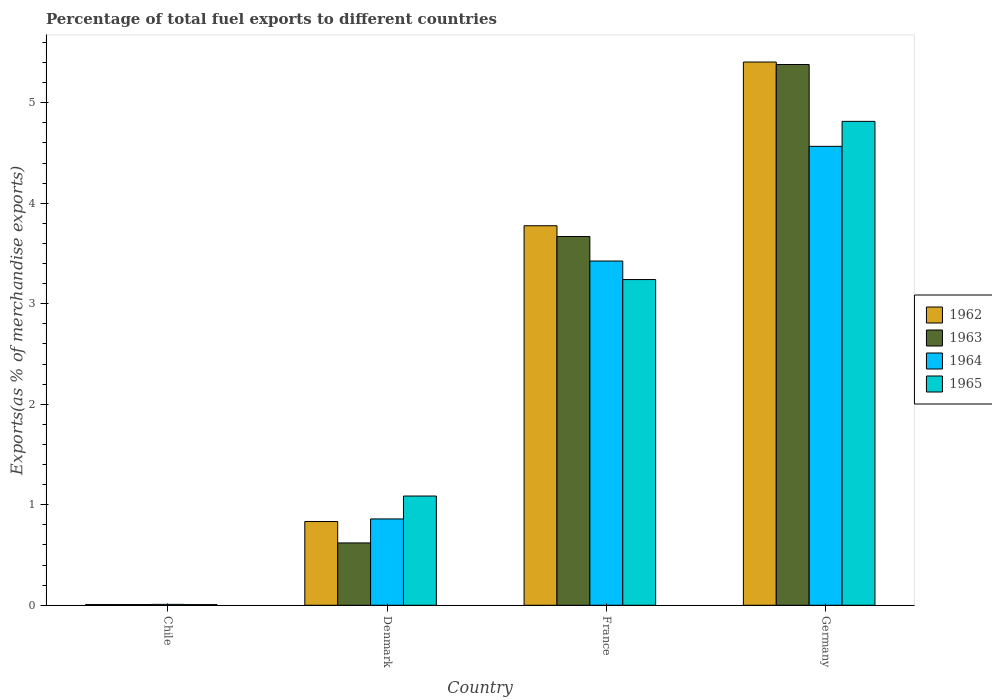How many groups of bars are there?
Ensure brevity in your answer.  4. Are the number of bars on each tick of the X-axis equal?
Make the answer very short. Yes. In how many cases, is the number of bars for a given country not equal to the number of legend labels?
Ensure brevity in your answer.  0. What is the percentage of exports to different countries in 1962 in Denmark?
Give a very brief answer. 0.83. Across all countries, what is the maximum percentage of exports to different countries in 1962?
Give a very brief answer. 5.4. Across all countries, what is the minimum percentage of exports to different countries in 1965?
Your response must be concise. 0.01. In which country was the percentage of exports to different countries in 1962 maximum?
Your answer should be very brief. Germany. What is the total percentage of exports to different countries in 1963 in the graph?
Your answer should be very brief. 9.68. What is the difference between the percentage of exports to different countries in 1962 in Chile and that in Denmark?
Keep it short and to the point. -0.83. What is the difference between the percentage of exports to different countries in 1962 in Chile and the percentage of exports to different countries in 1965 in Denmark?
Your response must be concise. -1.08. What is the average percentage of exports to different countries in 1962 per country?
Offer a very short reply. 2.51. What is the difference between the percentage of exports to different countries of/in 1962 and percentage of exports to different countries of/in 1963 in Denmark?
Provide a succinct answer. 0.21. What is the ratio of the percentage of exports to different countries in 1963 in Denmark to that in France?
Make the answer very short. 0.17. Is the percentage of exports to different countries in 1963 in Chile less than that in Denmark?
Ensure brevity in your answer.  Yes. Is the difference between the percentage of exports to different countries in 1962 in France and Germany greater than the difference between the percentage of exports to different countries in 1963 in France and Germany?
Provide a short and direct response. Yes. What is the difference between the highest and the second highest percentage of exports to different countries in 1965?
Make the answer very short. -2.15. What is the difference between the highest and the lowest percentage of exports to different countries in 1963?
Your response must be concise. 5.37. What does the 2nd bar from the left in Denmark represents?
Provide a short and direct response. 1963. What does the 1st bar from the right in Denmark represents?
Offer a very short reply. 1965. Is it the case that in every country, the sum of the percentage of exports to different countries in 1962 and percentage of exports to different countries in 1963 is greater than the percentage of exports to different countries in 1964?
Offer a very short reply. Yes. Are the values on the major ticks of Y-axis written in scientific E-notation?
Make the answer very short. No. Does the graph contain grids?
Offer a very short reply. No. Where does the legend appear in the graph?
Your answer should be very brief. Center right. How are the legend labels stacked?
Your response must be concise. Vertical. What is the title of the graph?
Provide a short and direct response. Percentage of total fuel exports to different countries. What is the label or title of the X-axis?
Your answer should be compact. Country. What is the label or title of the Y-axis?
Keep it short and to the point. Exports(as % of merchandise exports). What is the Exports(as % of merchandise exports) in 1962 in Chile?
Make the answer very short. 0.01. What is the Exports(as % of merchandise exports) of 1963 in Chile?
Provide a succinct answer. 0.01. What is the Exports(as % of merchandise exports) in 1964 in Chile?
Ensure brevity in your answer.  0.01. What is the Exports(as % of merchandise exports) of 1965 in Chile?
Offer a very short reply. 0.01. What is the Exports(as % of merchandise exports) in 1962 in Denmark?
Provide a short and direct response. 0.83. What is the Exports(as % of merchandise exports) in 1963 in Denmark?
Keep it short and to the point. 0.62. What is the Exports(as % of merchandise exports) in 1964 in Denmark?
Give a very brief answer. 0.86. What is the Exports(as % of merchandise exports) in 1965 in Denmark?
Make the answer very short. 1.09. What is the Exports(as % of merchandise exports) in 1962 in France?
Offer a very short reply. 3.78. What is the Exports(as % of merchandise exports) in 1963 in France?
Give a very brief answer. 3.67. What is the Exports(as % of merchandise exports) in 1964 in France?
Give a very brief answer. 3.43. What is the Exports(as % of merchandise exports) in 1965 in France?
Offer a terse response. 3.24. What is the Exports(as % of merchandise exports) in 1962 in Germany?
Your answer should be compact. 5.4. What is the Exports(as % of merchandise exports) in 1963 in Germany?
Your response must be concise. 5.38. What is the Exports(as % of merchandise exports) of 1964 in Germany?
Provide a short and direct response. 4.57. What is the Exports(as % of merchandise exports) in 1965 in Germany?
Ensure brevity in your answer.  4.81. Across all countries, what is the maximum Exports(as % of merchandise exports) in 1962?
Give a very brief answer. 5.4. Across all countries, what is the maximum Exports(as % of merchandise exports) of 1963?
Offer a very short reply. 5.38. Across all countries, what is the maximum Exports(as % of merchandise exports) in 1964?
Your response must be concise. 4.57. Across all countries, what is the maximum Exports(as % of merchandise exports) of 1965?
Offer a terse response. 4.81. Across all countries, what is the minimum Exports(as % of merchandise exports) of 1962?
Provide a short and direct response. 0.01. Across all countries, what is the minimum Exports(as % of merchandise exports) in 1963?
Give a very brief answer. 0.01. Across all countries, what is the minimum Exports(as % of merchandise exports) in 1964?
Offer a very short reply. 0.01. Across all countries, what is the minimum Exports(as % of merchandise exports) in 1965?
Make the answer very short. 0.01. What is the total Exports(as % of merchandise exports) of 1962 in the graph?
Provide a succinct answer. 10.02. What is the total Exports(as % of merchandise exports) of 1963 in the graph?
Offer a very short reply. 9.68. What is the total Exports(as % of merchandise exports) in 1964 in the graph?
Your response must be concise. 8.86. What is the total Exports(as % of merchandise exports) of 1965 in the graph?
Offer a terse response. 9.15. What is the difference between the Exports(as % of merchandise exports) in 1962 in Chile and that in Denmark?
Provide a succinct answer. -0.83. What is the difference between the Exports(as % of merchandise exports) of 1963 in Chile and that in Denmark?
Ensure brevity in your answer.  -0.61. What is the difference between the Exports(as % of merchandise exports) of 1964 in Chile and that in Denmark?
Your answer should be compact. -0.85. What is the difference between the Exports(as % of merchandise exports) in 1965 in Chile and that in Denmark?
Offer a very short reply. -1.08. What is the difference between the Exports(as % of merchandise exports) in 1962 in Chile and that in France?
Your answer should be compact. -3.77. What is the difference between the Exports(as % of merchandise exports) of 1963 in Chile and that in France?
Offer a very short reply. -3.66. What is the difference between the Exports(as % of merchandise exports) in 1964 in Chile and that in France?
Keep it short and to the point. -3.42. What is the difference between the Exports(as % of merchandise exports) of 1965 in Chile and that in France?
Provide a short and direct response. -3.23. What is the difference between the Exports(as % of merchandise exports) of 1962 in Chile and that in Germany?
Provide a succinct answer. -5.4. What is the difference between the Exports(as % of merchandise exports) of 1963 in Chile and that in Germany?
Offer a terse response. -5.37. What is the difference between the Exports(as % of merchandise exports) of 1964 in Chile and that in Germany?
Your answer should be compact. -4.56. What is the difference between the Exports(as % of merchandise exports) in 1965 in Chile and that in Germany?
Ensure brevity in your answer.  -4.81. What is the difference between the Exports(as % of merchandise exports) of 1962 in Denmark and that in France?
Make the answer very short. -2.94. What is the difference between the Exports(as % of merchandise exports) in 1963 in Denmark and that in France?
Provide a succinct answer. -3.05. What is the difference between the Exports(as % of merchandise exports) in 1964 in Denmark and that in France?
Provide a succinct answer. -2.57. What is the difference between the Exports(as % of merchandise exports) of 1965 in Denmark and that in France?
Offer a very short reply. -2.15. What is the difference between the Exports(as % of merchandise exports) of 1962 in Denmark and that in Germany?
Keep it short and to the point. -4.57. What is the difference between the Exports(as % of merchandise exports) in 1963 in Denmark and that in Germany?
Your answer should be compact. -4.76. What is the difference between the Exports(as % of merchandise exports) of 1964 in Denmark and that in Germany?
Your response must be concise. -3.71. What is the difference between the Exports(as % of merchandise exports) of 1965 in Denmark and that in Germany?
Keep it short and to the point. -3.73. What is the difference between the Exports(as % of merchandise exports) of 1962 in France and that in Germany?
Provide a short and direct response. -1.63. What is the difference between the Exports(as % of merchandise exports) in 1963 in France and that in Germany?
Provide a short and direct response. -1.71. What is the difference between the Exports(as % of merchandise exports) of 1964 in France and that in Germany?
Offer a very short reply. -1.14. What is the difference between the Exports(as % of merchandise exports) of 1965 in France and that in Germany?
Provide a succinct answer. -1.57. What is the difference between the Exports(as % of merchandise exports) in 1962 in Chile and the Exports(as % of merchandise exports) in 1963 in Denmark?
Provide a short and direct response. -0.61. What is the difference between the Exports(as % of merchandise exports) in 1962 in Chile and the Exports(as % of merchandise exports) in 1964 in Denmark?
Ensure brevity in your answer.  -0.85. What is the difference between the Exports(as % of merchandise exports) in 1962 in Chile and the Exports(as % of merchandise exports) in 1965 in Denmark?
Ensure brevity in your answer.  -1.08. What is the difference between the Exports(as % of merchandise exports) of 1963 in Chile and the Exports(as % of merchandise exports) of 1964 in Denmark?
Provide a succinct answer. -0.85. What is the difference between the Exports(as % of merchandise exports) of 1963 in Chile and the Exports(as % of merchandise exports) of 1965 in Denmark?
Give a very brief answer. -1.08. What is the difference between the Exports(as % of merchandise exports) in 1964 in Chile and the Exports(as % of merchandise exports) in 1965 in Denmark?
Offer a terse response. -1.08. What is the difference between the Exports(as % of merchandise exports) of 1962 in Chile and the Exports(as % of merchandise exports) of 1963 in France?
Offer a terse response. -3.66. What is the difference between the Exports(as % of merchandise exports) in 1962 in Chile and the Exports(as % of merchandise exports) in 1964 in France?
Provide a short and direct response. -3.42. What is the difference between the Exports(as % of merchandise exports) in 1962 in Chile and the Exports(as % of merchandise exports) in 1965 in France?
Your response must be concise. -3.23. What is the difference between the Exports(as % of merchandise exports) of 1963 in Chile and the Exports(as % of merchandise exports) of 1964 in France?
Ensure brevity in your answer.  -3.42. What is the difference between the Exports(as % of merchandise exports) in 1963 in Chile and the Exports(as % of merchandise exports) in 1965 in France?
Keep it short and to the point. -3.23. What is the difference between the Exports(as % of merchandise exports) of 1964 in Chile and the Exports(as % of merchandise exports) of 1965 in France?
Give a very brief answer. -3.23. What is the difference between the Exports(as % of merchandise exports) in 1962 in Chile and the Exports(as % of merchandise exports) in 1963 in Germany?
Keep it short and to the point. -5.37. What is the difference between the Exports(as % of merchandise exports) in 1962 in Chile and the Exports(as % of merchandise exports) in 1964 in Germany?
Ensure brevity in your answer.  -4.56. What is the difference between the Exports(as % of merchandise exports) of 1962 in Chile and the Exports(as % of merchandise exports) of 1965 in Germany?
Give a very brief answer. -4.81. What is the difference between the Exports(as % of merchandise exports) of 1963 in Chile and the Exports(as % of merchandise exports) of 1964 in Germany?
Your answer should be compact. -4.56. What is the difference between the Exports(as % of merchandise exports) of 1963 in Chile and the Exports(as % of merchandise exports) of 1965 in Germany?
Your answer should be compact. -4.81. What is the difference between the Exports(as % of merchandise exports) in 1964 in Chile and the Exports(as % of merchandise exports) in 1965 in Germany?
Ensure brevity in your answer.  -4.81. What is the difference between the Exports(as % of merchandise exports) in 1962 in Denmark and the Exports(as % of merchandise exports) in 1963 in France?
Offer a terse response. -2.84. What is the difference between the Exports(as % of merchandise exports) in 1962 in Denmark and the Exports(as % of merchandise exports) in 1964 in France?
Provide a short and direct response. -2.59. What is the difference between the Exports(as % of merchandise exports) of 1962 in Denmark and the Exports(as % of merchandise exports) of 1965 in France?
Your answer should be very brief. -2.41. What is the difference between the Exports(as % of merchandise exports) of 1963 in Denmark and the Exports(as % of merchandise exports) of 1964 in France?
Provide a succinct answer. -2.8. What is the difference between the Exports(as % of merchandise exports) of 1963 in Denmark and the Exports(as % of merchandise exports) of 1965 in France?
Provide a succinct answer. -2.62. What is the difference between the Exports(as % of merchandise exports) of 1964 in Denmark and the Exports(as % of merchandise exports) of 1965 in France?
Offer a terse response. -2.38. What is the difference between the Exports(as % of merchandise exports) in 1962 in Denmark and the Exports(as % of merchandise exports) in 1963 in Germany?
Provide a succinct answer. -4.55. What is the difference between the Exports(as % of merchandise exports) of 1962 in Denmark and the Exports(as % of merchandise exports) of 1964 in Germany?
Give a very brief answer. -3.73. What is the difference between the Exports(as % of merchandise exports) in 1962 in Denmark and the Exports(as % of merchandise exports) in 1965 in Germany?
Ensure brevity in your answer.  -3.98. What is the difference between the Exports(as % of merchandise exports) in 1963 in Denmark and the Exports(as % of merchandise exports) in 1964 in Germany?
Your answer should be very brief. -3.95. What is the difference between the Exports(as % of merchandise exports) of 1963 in Denmark and the Exports(as % of merchandise exports) of 1965 in Germany?
Your answer should be very brief. -4.19. What is the difference between the Exports(as % of merchandise exports) of 1964 in Denmark and the Exports(as % of merchandise exports) of 1965 in Germany?
Your response must be concise. -3.96. What is the difference between the Exports(as % of merchandise exports) in 1962 in France and the Exports(as % of merchandise exports) in 1963 in Germany?
Your answer should be compact. -1.6. What is the difference between the Exports(as % of merchandise exports) of 1962 in France and the Exports(as % of merchandise exports) of 1964 in Germany?
Offer a terse response. -0.79. What is the difference between the Exports(as % of merchandise exports) of 1962 in France and the Exports(as % of merchandise exports) of 1965 in Germany?
Make the answer very short. -1.04. What is the difference between the Exports(as % of merchandise exports) of 1963 in France and the Exports(as % of merchandise exports) of 1964 in Germany?
Offer a terse response. -0.9. What is the difference between the Exports(as % of merchandise exports) of 1963 in France and the Exports(as % of merchandise exports) of 1965 in Germany?
Offer a very short reply. -1.15. What is the difference between the Exports(as % of merchandise exports) in 1964 in France and the Exports(as % of merchandise exports) in 1965 in Germany?
Keep it short and to the point. -1.39. What is the average Exports(as % of merchandise exports) of 1962 per country?
Ensure brevity in your answer.  2.51. What is the average Exports(as % of merchandise exports) of 1963 per country?
Provide a succinct answer. 2.42. What is the average Exports(as % of merchandise exports) in 1964 per country?
Ensure brevity in your answer.  2.21. What is the average Exports(as % of merchandise exports) of 1965 per country?
Keep it short and to the point. 2.29. What is the difference between the Exports(as % of merchandise exports) of 1962 and Exports(as % of merchandise exports) of 1963 in Chile?
Your answer should be very brief. -0. What is the difference between the Exports(as % of merchandise exports) in 1962 and Exports(as % of merchandise exports) in 1964 in Chile?
Your response must be concise. -0. What is the difference between the Exports(as % of merchandise exports) in 1963 and Exports(as % of merchandise exports) in 1964 in Chile?
Offer a terse response. -0. What is the difference between the Exports(as % of merchandise exports) in 1963 and Exports(as % of merchandise exports) in 1965 in Chile?
Your answer should be compact. 0. What is the difference between the Exports(as % of merchandise exports) in 1964 and Exports(as % of merchandise exports) in 1965 in Chile?
Your response must be concise. 0. What is the difference between the Exports(as % of merchandise exports) of 1962 and Exports(as % of merchandise exports) of 1963 in Denmark?
Your response must be concise. 0.21. What is the difference between the Exports(as % of merchandise exports) of 1962 and Exports(as % of merchandise exports) of 1964 in Denmark?
Keep it short and to the point. -0.03. What is the difference between the Exports(as % of merchandise exports) of 1962 and Exports(as % of merchandise exports) of 1965 in Denmark?
Offer a very short reply. -0.25. What is the difference between the Exports(as % of merchandise exports) in 1963 and Exports(as % of merchandise exports) in 1964 in Denmark?
Provide a succinct answer. -0.24. What is the difference between the Exports(as % of merchandise exports) of 1963 and Exports(as % of merchandise exports) of 1965 in Denmark?
Your answer should be very brief. -0.47. What is the difference between the Exports(as % of merchandise exports) in 1964 and Exports(as % of merchandise exports) in 1965 in Denmark?
Give a very brief answer. -0.23. What is the difference between the Exports(as % of merchandise exports) in 1962 and Exports(as % of merchandise exports) in 1963 in France?
Provide a succinct answer. 0.11. What is the difference between the Exports(as % of merchandise exports) in 1962 and Exports(as % of merchandise exports) in 1964 in France?
Your response must be concise. 0.35. What is the difference between the Exports(as % of merchandise exports) of 1962 and Exports(as % of merchandise exports) of 1965 in France?
Ensure brevity in your answer.  0.54. What is the difference between the Exports(as % of merchandise exports) in 1963 and Exports(as % of merchandise exports) in 1964 in France?
Your answer should be very brief. 0.24. What is the difference between the Exports(as % of merchandise exports) of 1963 and Exports(as % of merchandise exports) of 1965 in France?
Provide a short and direct response. 0.43. What is the difference between the Exports(as % of merchandise exports) in 1964 and Exports(as % of merchandise exports) in 1965 in France?
Offer a very short reply. 0.18. What is the difference between the Exports(as % of merchandise exports) in 1962 and Exports(as % of merchandise exports) in 1963 in Germany?
Keep it short and to the point. 0.02. What is the difference between the Exports(as % of merchandise exports) of 1962 and Exports(as % of merchandise exports) of 1964 in Germany?
Offer a terse response. 0.84. What is the difference between the Exports(as % of merchandise exports) in 1962 and Exports(as % of merchandise exports) in 1965 in Germany?
Provide a succinct answer. 0.59. What is the difference between the Exports(as % of merchandise exports) of 1963 and Exports(as % of merchandise exports) of 1964 in Germany?
Offer a very short reply. 0.81. What is the difference between the Exports(as % of merchandise exports) in 1963 and Exports(as % of merchandise exports) in 1965 in Germany?
Provide a succinct answer. 0.57. What is the difference between the Exports(as % of merchandise exports) of 1964 and Exports(as % of merchandise exports) of 1965 in Germany?
Give a very brief answer. -0.25. What is the ratio of the Exports(as % of merchandise exports) of 1962 in Chile to that in Denmark?
Keep it short and to the point. 0.01. What is the ratio of the Exports(as % of merchandise exports) of 1963 in Chile to that in Denmark?
Make the answer very short. 0.01. What is the ratio of the Exports(as % of merchandise exports) of 1964 in Chile to that in Denmark?
Keep it short and to the point. 0.01. What is the ratio of the Exports(as % of merchandise exports) in 1965 in Chile to that in Denmark?
Give a very brief answer. 0.01. What is the ratio of the Exports(as % of merchandise exports) of 1962 in Chile to that in France?
Provide a short and direct response. 0. What is the ratio of the Exports(as % of merchandise exports) of 1963 in Chile to that in France?
Keep it short and to the point. 0. What is the ratio of the Exports(as % of merchandise exports) of 1964 in Chile to that in France?
Keep it short and to the point. 0. What is the ratio of the Exports(as % of merchandise exports) of 1965 in Chile to that in France?
Your response must be concise. 0. What is the ratio of the Exports(as % of merchandise exports) of 1962 in Chile to that in Germany?
Keep it short and to the point. 0. What is the ratio of the Exports(as % of merchandise exports) in 1963 in Chile to that in Germany?
Keep it short and to the point. 0. What is the ratio of the Exports(as % of merchandise exports) in 1964 in Chile to that in Germany?
Your answer should be very brief. 0. What is the ratio of the Exports(as % of merchandise exports) of 1965 in Chile to that in Germany?
Give a very brief answer. 0. What is the ratio of the Exports(as % of merchandise exports) in 1962 in Denmark to that in France?
Your answer should be compact. 0.22. What is the ratio of the Exports(as % of merchandise exports) in 1963 in Denmark to that in France?
Your answer should be compact. 0.17. What is the ratio of the Exports(as % of merchandise exports) in 1964 in Denmark to that in France?
Give a very brief answer. 0.25. What is the ratio of the Exports(as % of merchandise exports) in 1965 in Denmark to that in France?
Make the answer very short. 0.34. What is the ratio of the Exports(as % of merchandise exports) in 1962 in Denmark to that in Germany?
Make the answer very short. 0.15. What is the ratio of the Exports(as % of merchandise exports) in 1963 in Denmark to that in Germany?
Provide a succinct answer. 0.12. What is the ratio of the Exports(as % of merchandise exports) of 1964 in Denmark to that in Germany?
Provide a short and direct response. 0.19. What is the ratio of the Exports(as % of merchandise exports) in 1965 in Denmark to that in Germany?
Offer a terse response. 0.23. What is the ratio of the Exports(as % of merchandise exports) of 1962 in France to that in Germany?
Your answer should be very brief. 0.7. What is the ratio of the Exports(as % of merchandise exports) in 1963 in France to that in Germany?
Offer a very short reply. 0.68. What is the ratio of the Exports(as % of merchandise exports) in 1964 in France to that in Germany?
Make the answer very short. 0.75. What is the ratio of the Exports(as % of merchandise exports) in 1965 in France to that in Germany?
Your answer should be compact. 0.67. What is the difference between the highest and the second highest Exports(as % of merchandise exports) of 1962?
Give a very brief answer. 1.63. What is the difference between the highest and the second highest Exports(as % of merchandise exports) of 1963?
Provide a succinct answer. 1.71. What is the difference between the highest and the second highest Exports(as % of merchandise exports) of 1964?
Provide a short and direct response. 1.14. What is the difference between the highest and the second highest Exports(as % of merchandise exports) of 1965?
Give a very brief answer. 1.57. What is the difference between the highest and the lowest Exports(as % of merchandise exports) of 1962?
Offer a terse response. 5.4. What is the difference between the highest and the lowest Exports(as % of merchandise exports) of 1963?
Offer a terse response. 5.37. What is the difference between the highest and the lowest Exports(as % of merchandise exports) of 1964?
Keep it short and to the point. 4.56. What is the difference between the highest and the lowest Exports(as % of merchandise exports) of 1965?
Provide a succinct answer. 4.81. 